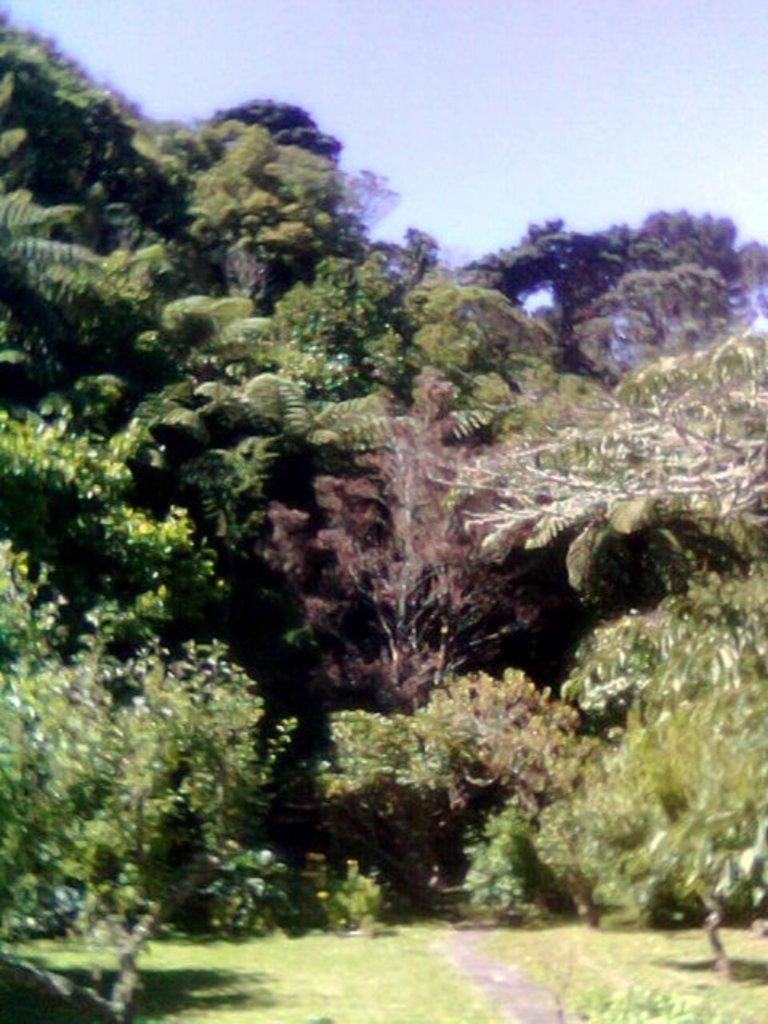What type of vegetation is present in the image? There is grass in the image. How many trees can be seen in the image? There are multiple trees in the image. Where are the trees located in the image? The trees are in the middle of the image. What can be seen in the background of the image? The sky is visible in the background of the image. Is there a wall surrounding the trees in the image? There is no wall present in the image; it only features grass, trees, and the sky. Can you see a carriage being pulled by horses in the image? There is no carriage or horses present in the image. 